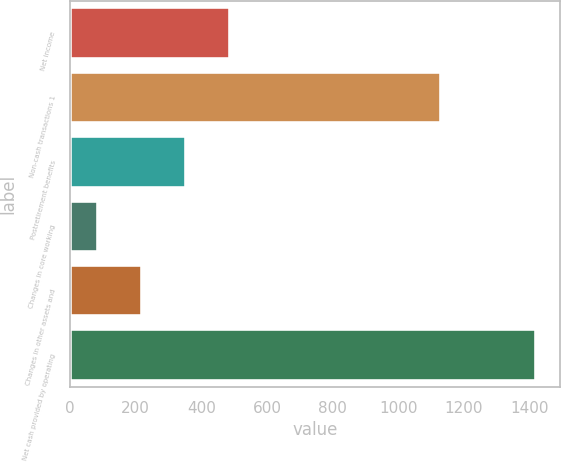Convert chart. <chart><loc_0><loc_0><loc_500><loc_500><bar_chart><fcel>Net income<fcel>Non-cash transactions 1<fcel>Postretirement benefits<fcel>Changes in core working<fcel>Changes in other assets and<fcel>Net cash provided by operating<nl><fcel>486.5<fcel>1129<fcel>353<fcel>86<fcel>219.5<fcel>1421<nl></chart> 